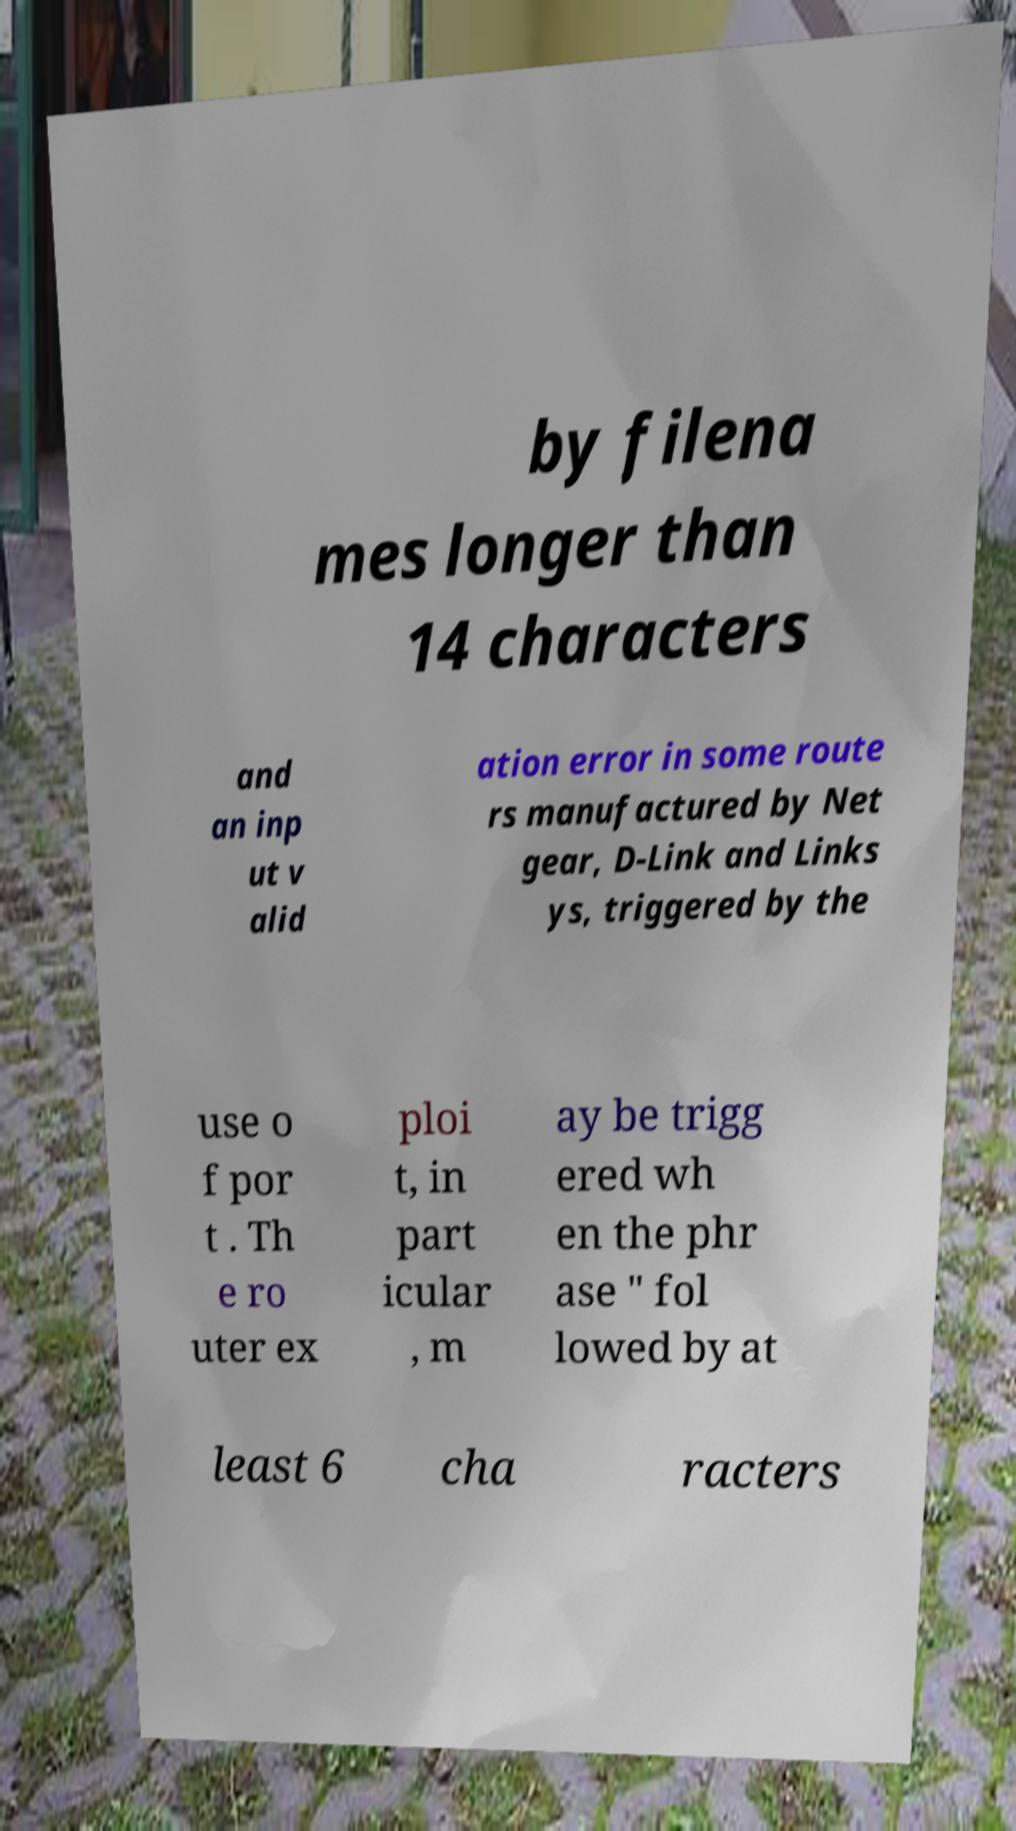Please read and relay the text visible in this image. What does it say? by filena mes longer than 14 characters and an inp ut v alid ation error in some route rs manufactured by Net gear, D-Link and Links ys, triggered by the use o f por t . Th e ro uter ex ploi t, in part icular , m ay be trigg ered wh en the phr ase " fol lowed by at least 6 cha racters 